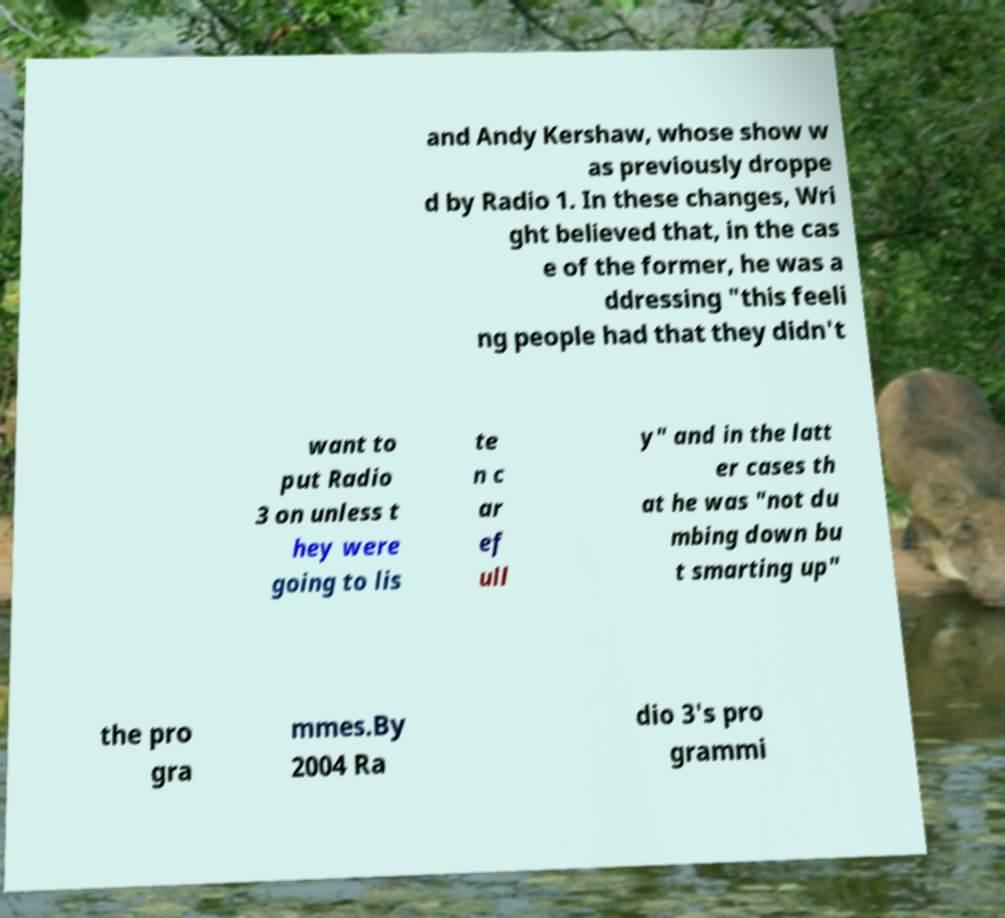Can you accurately transcribe the text from the provided image for me? and Andy Kershaw, whose show w as previously droppe d by Radio 1. In these changes, Wri ght believed that, in the cas e of the former, he was a ddressing "this feeli ng people had that they didn't want to put Radio 3 on unless t hey were going to lis te n c ar ef ull y" and in the latt er cases th at he was "not du mbing down bu t smarting up" the pro gra mmes.By 2004 Ra dio 3's pro grammi 